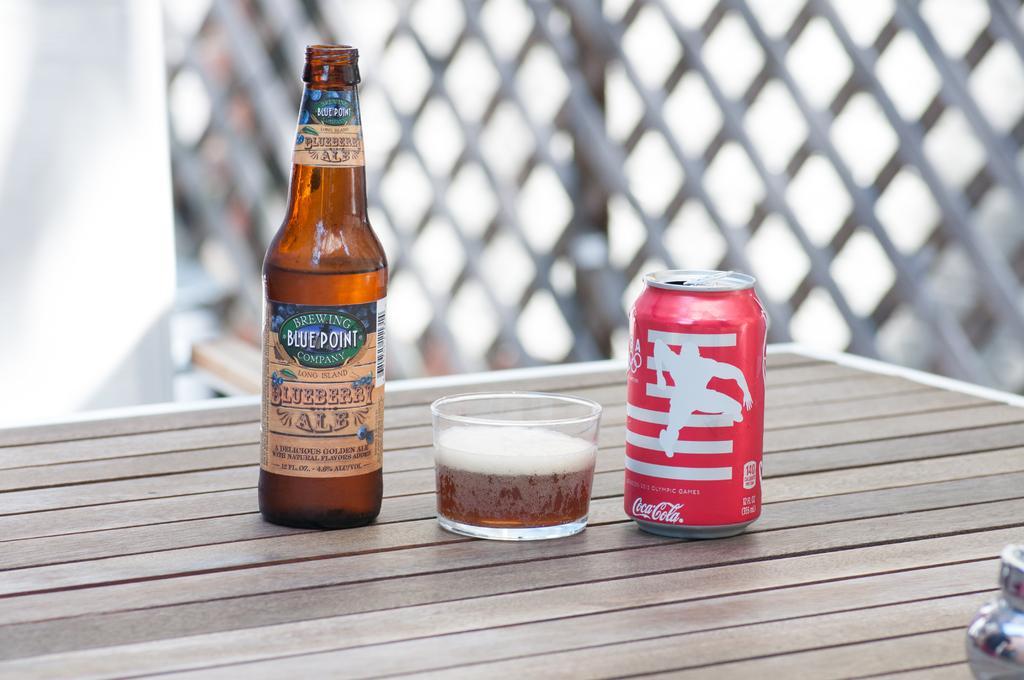Can you describe this image briefly? In the image we can see wooden table, on the table, we can see the bottle, can, glass and in the glass we can see the liquid. Here we can see the fence and the background is blurred. 